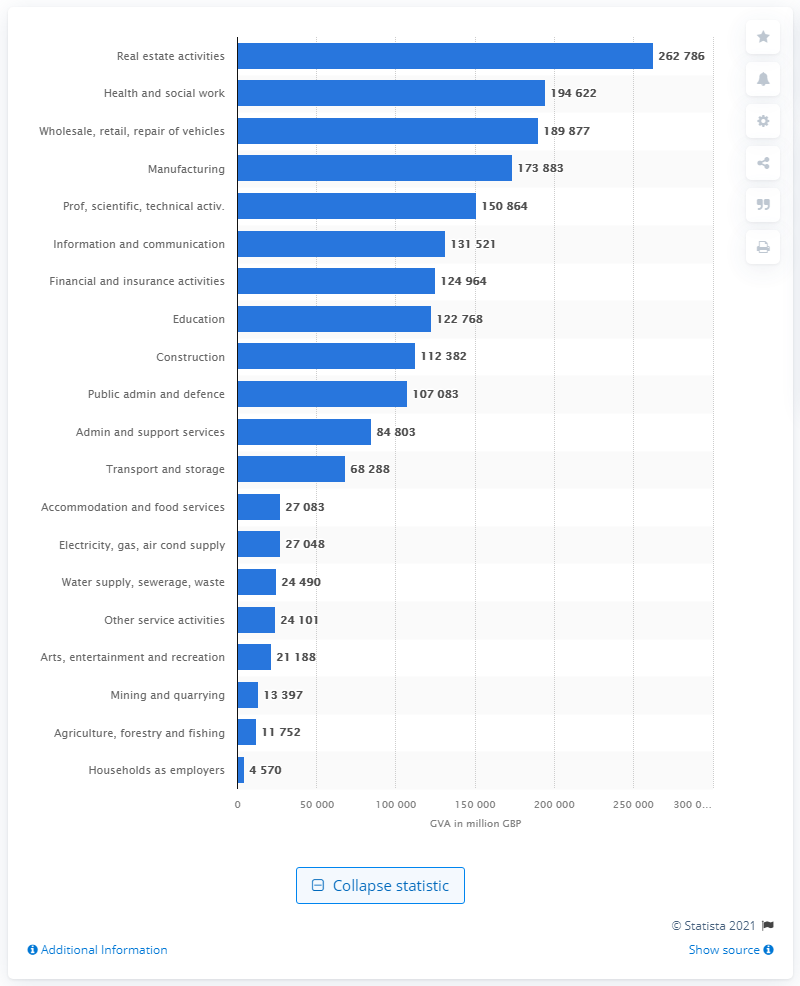Indicate a few pertinent items in this graphic. The gross value added of the real estate sector in the UK for the year ending March 2021 was approximately 262,786. 